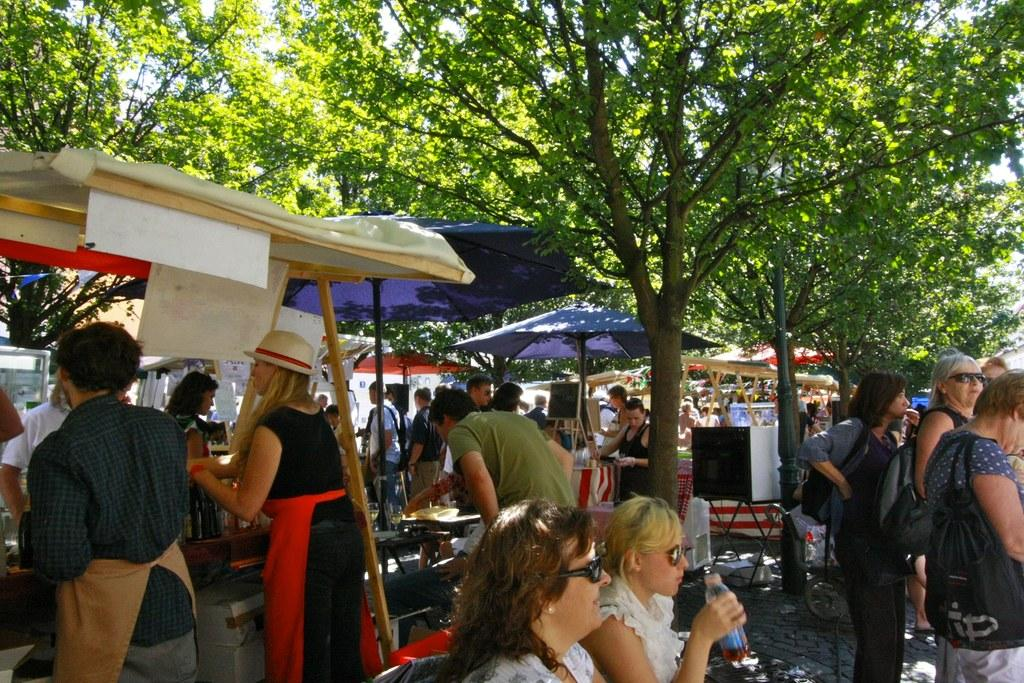What type of structures are present in the image? There are stalls in the image. What can be seen in the middle of the stalls? There is a pole in the image. Are there any people in the image? Yes, there are people in the image. What is visible in the background of the image? There are trees in the background of the image. Where is the oven located in the image? There is no oven present in the image. How many feet can be seen in the image? There is no specific mention of feet in the image, so it cannot be determined how many are visible. 